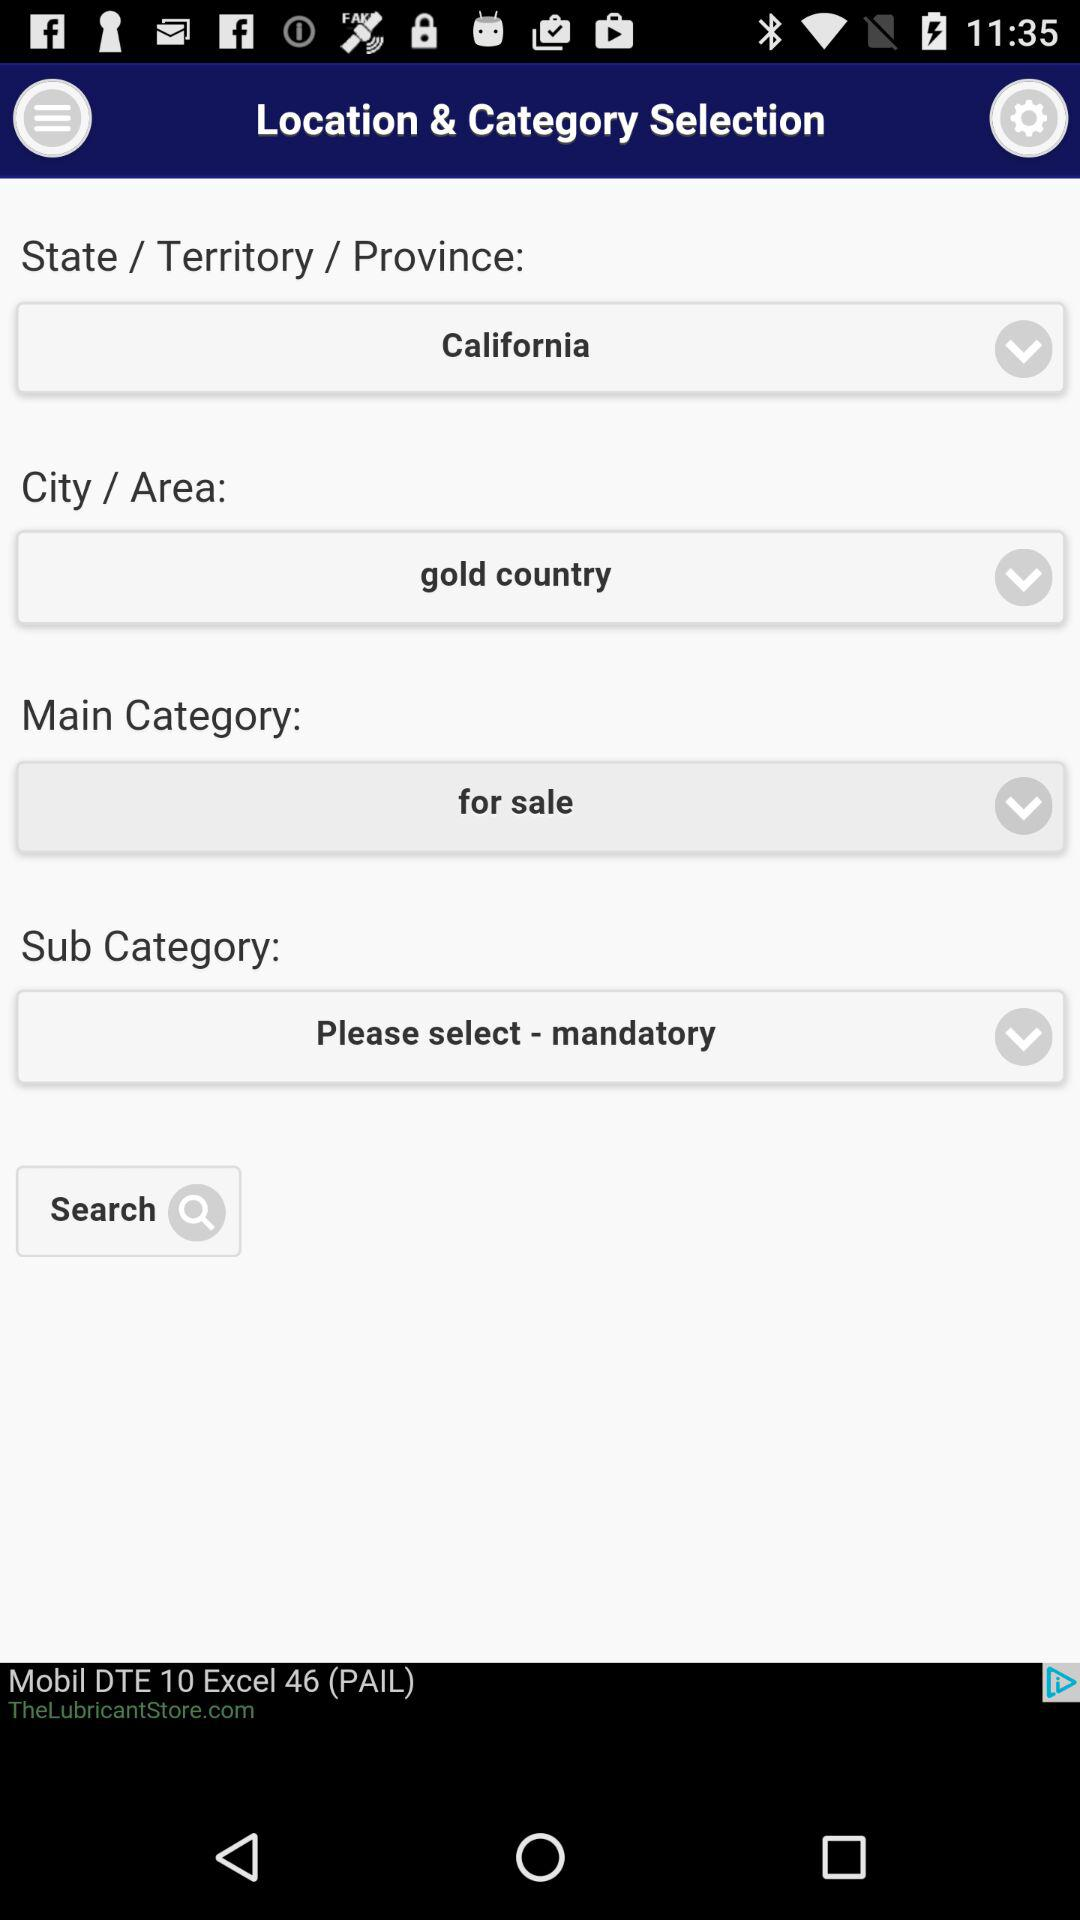What state is selected? The selected state is California. 